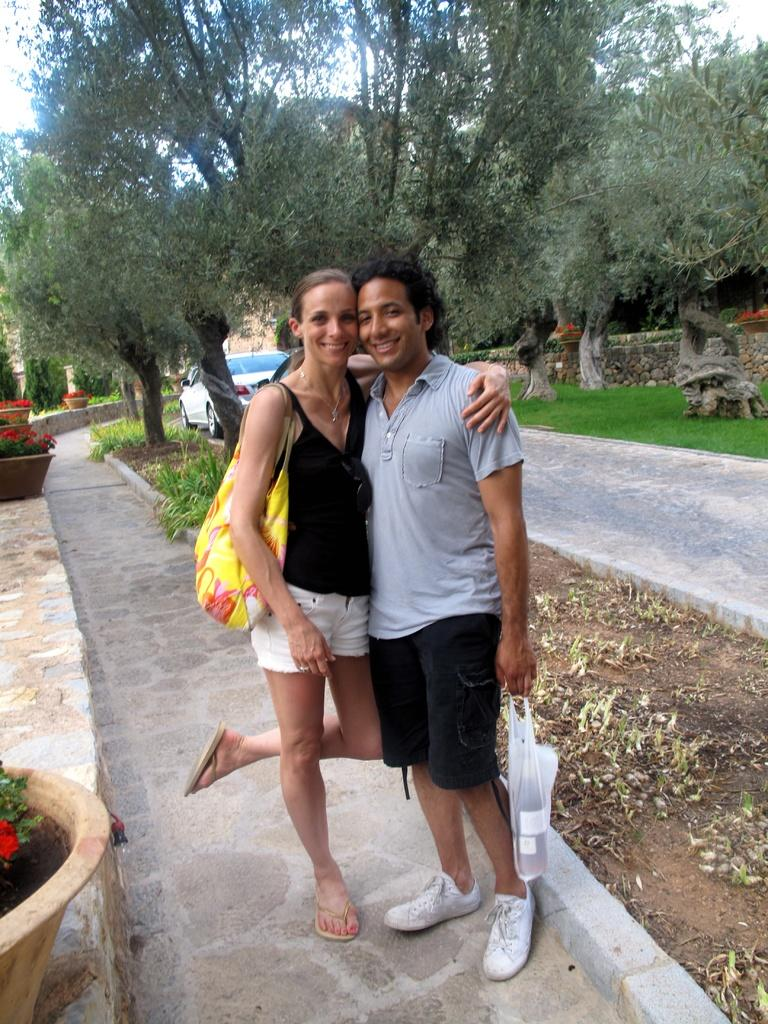Who are the people in the image? There is a man and a woman standing in the middle of the image. What are the expressions on their faces? The man and woman are smiling. What can be seen in the background of the image? There are trees visible at the back side of the image. Is there any evidence of iron being used in the image? There is no mention of iron or any iron-related objects in the image? Are there any fairies flying around the trees in the image? There is no mention of fairies or any fairy-related objects in the image. 